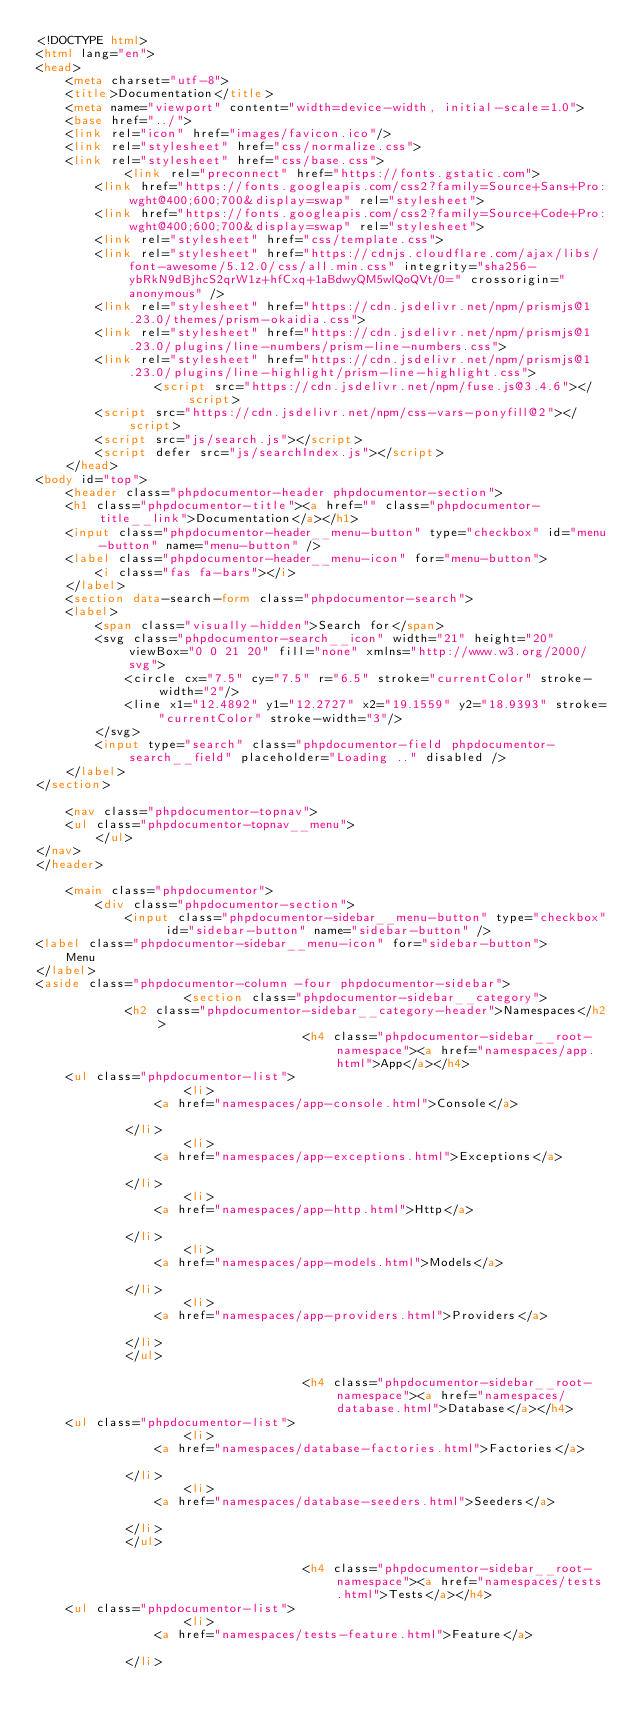<code> <loc_0><loc_0><loc_500><loc_500><_HTML_><!DOCTYPE html>
<html lang="en">
<head>
    <meta charset="utf-8">
    <title>Documentation</title>
    <meta name="viewport" content="width=device-width, initial-scale=1.0">
    <base href="../">
    <link rel="icon" href="images/favicon.ico"/>
    <link rel="stylesheet" href="css/normalize.css">
    <link rel="stylesheet" href="css/base.css">
            <link rel="preconnect" href="https://fonts.gstatic.com">
        <link href="https://fonts.googleapis.com/css2?family=Source+Sans+Pro:wght@400;600;700&display=swap" rel="stylesheet">
        <link href="https://fonts.googleapis.com/css2?family=Source+Code+Pro:wght@400;600;700&display=swap" rel="stylesheet">
        <link rel="stylesheet" href="css/template.css">
        <link rel="stylesheet" href="https://cdnjs.cloudflare.com/ajax/libs/font-awesome/5.12.0/css/all.min.css" integrity="sha256-ybRkN9dBjhcS2qrW1z+hfCxq+1aBdwyQM5wlQoQVt/0=" crossorigin="anonymous" />
        <link rel="stylesheet" href="https://cdn.jsdelivr.net/npm/prismjs@1.23.0/themes/prism-okaidia.css">
        <link rel="stylesheet" href="https://cdn.jsdelivr.net/npm/prismjs@1.23.0/plugins/line-numbers/prism-line-numbers.css">
        <link rel="stylesheet" href="https://cdn.jsdelivr.net/npm/prismjs@1.23.0/plugins/line-highlight/prism-line-highlight.css">
                <script src="https://cdn.jsdelivr.net/npm/fuse.js@3.4.6"></script>
        <script src="https://cdn.jsdelivr.net/npm/css-vars-ponyfill@2"></script>
        <script src="js/search.js"></script>
        <script defer src="js/searchIndex.js"></script>
    </head>
<body id="top">
    <header class="phpdocumentor-header phpdocumentor-section">
    <h1 class="phpdocumentor-title"><a href="" class="phpdocumentor-title__link">Documentation</a></h1>
    <input class="phpdocumentor-header__menu-button" type="checkbox" id="menu-button" name="menu-button" />
    <label class="phpdocumentor-header__menu-icon" for="menu-button">
        <i class="fas fa-bars"></i>
    </label>
    <section data-search-form class="phpdocumentor-search">
    <label>
        <span class="visually-hidden">Search for</span>
        <svg class="phpdocumentor-search__icon" width="21" height="20" viewBox="0 0 21 20" fill="none" xmlns="http://www.w3.org/2000/svg">
            <circle cx="7.5" cy="7.5" r="6.5" stroke="currentColor" stroke-width="2"/>
            <line x1="12.4892" y1="12.2727" x2="19.1559" y2="18.9393" stroke="currentColor" stroke-width="3"/>
        </svg>
        <input type="search" class="phpdocumentor-field phpdocumentor-search__field" placeholder="Loading .." disabled />
    </label>
</section>

    <nav class="phpdocumentor-topnav">
    <ul class="phpdocumentor-topnav__menu">
        </ul>
</nav>
</header>

    <main class="phpdocumentor">
        <div class="phpdocumentor-section">
            <input class="phpdocumentor-sidebar__menu-button" type="checkbox" id="sidebar-button" name="sidebar-button" />
<label class="phpdocumentor-sidebar__menu-icon" for="sidebar-button">
    Menu
</label>
<aside class="phpdocumentor-column -four phpdocumentor-sidebar">
                    <section class="phpdocumentor-sidebar__category">
            <h2 class="phpdocumentor-sidebar__category-header">Namespaces</h2>
                                    <h4 class="phpdocumentor-sidebar__root-namespace"><a href="namespaces/app.html">App</a></h4>
    <ul class="phpdocumentor-list">
                    <li>
                <a href="namespaces/app-console.html">Console</a>
                
            </li>
                    <li>
                <a href="namespaces/app-exceptions.html">Exceptions</a>
                
            </li>
                    <li>
                <a href="namespaces/app-http.html">Http</a>
                
            </li>
                    <li>
                <a href="namespaces/app-models.html">Models</a>
                
            </li>
                    <li>
                <a href="namespaces/app-providers.html">Providers</a>
                
            </li>
            </ul>

                                    <h4 class="phpdocumentor-sidebar__root-namespace"><a href="namespaces/database.html">Database</a></h4>
    <ul class="phpdocumentor-list">
                    <li>
                <a href="namespaces/database-factories.html">Factories</a>
                
            </li>
                    <li>
                <a href="namespaces/database-seeders.html">Seeders</a>
                
            </li>
            </ul>

                                    <h4 class="phpdocumentor-sidebar__root-namespace"><a href="namespaces/tests.html">Tests</a></h4>
    <ul class="phpdocumentor-list">
                    <li>
                <a href="namespaces/tests-feature.html">Feature</a>
                
            </li></code> 